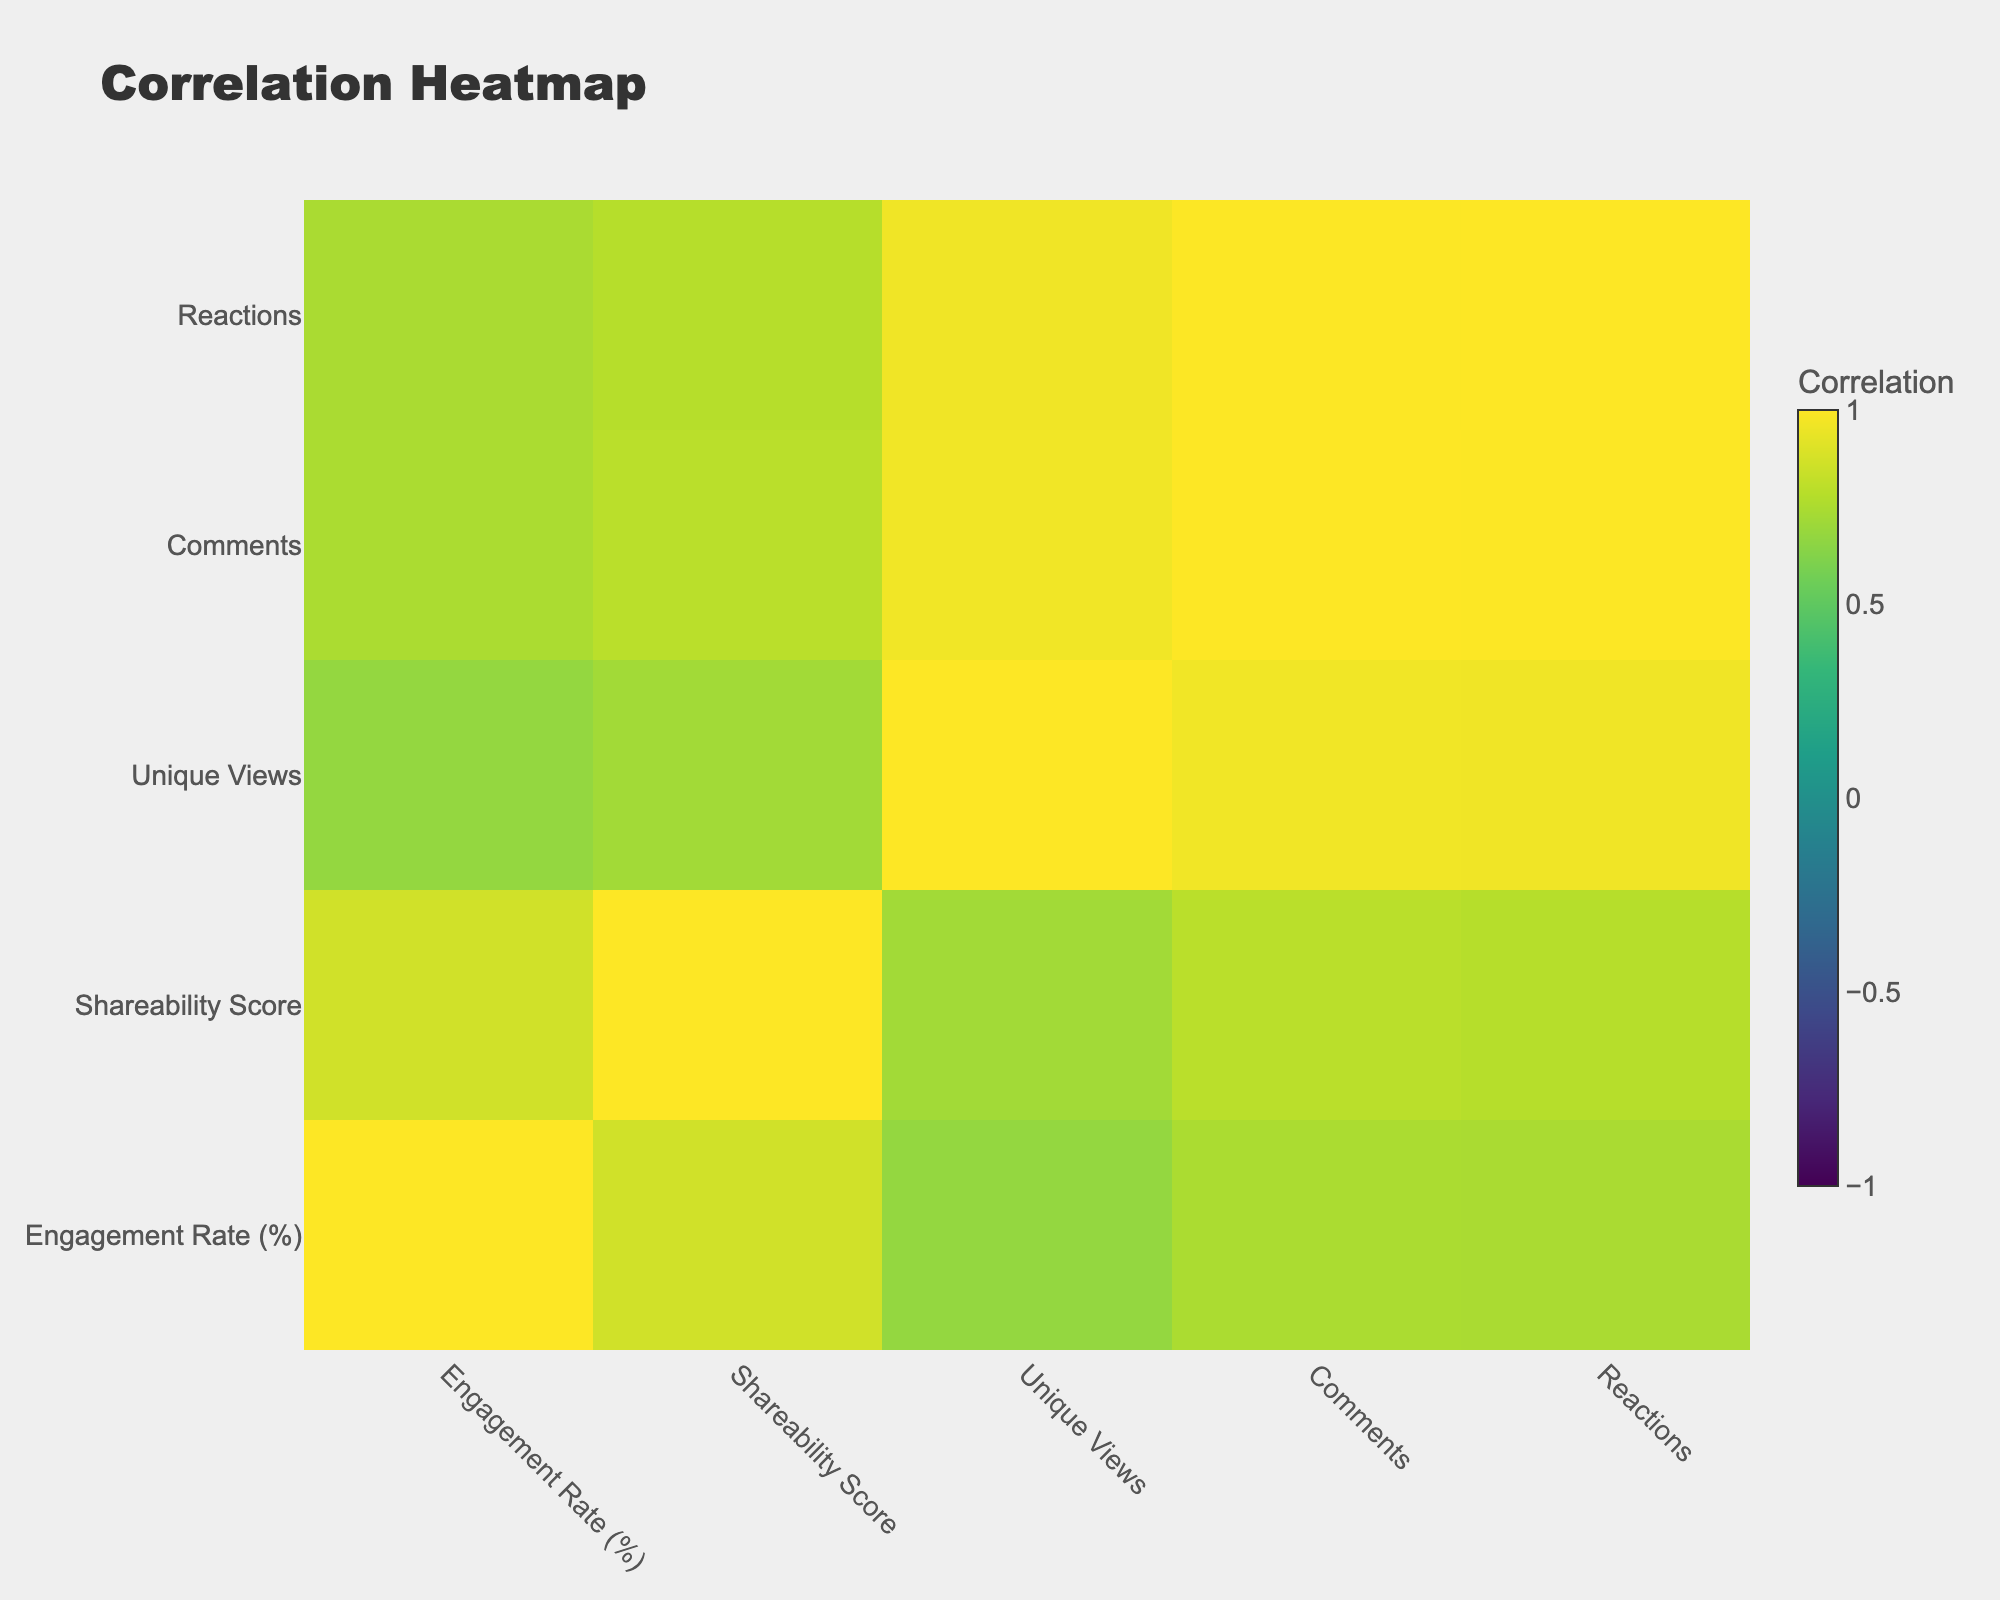What is the Shareability Score of TikTok? TikTok has a Shareability Score of 90, as shown directly in the table under the respective column for that platform.
Answer: 90 What is the Engagement Rate of YouTube? YouTube's Engagement Rate, based on the table, is 7.5%. This value can be found directly in the engagement rate column corresponding to YouTube.
Answer: 7.5 Which platform has the highest number of Unique Views? YouTube has the highest number of Unique Views with 4000. This can be seen by comparing the Unique Views for all platforms listed in the table.
Answer: 4000 Is the statement "Instagram has a higher Engagement Rate than Pinterest" true? Instagram has an Engagement Rate of 4.5% while Pinterest has a lower Engagement Rate of 4.0%. Since 4.5 is greater than 4.0, the statement is true.
Answer: Yes What is the average Shareability Score for all platforms? To calculate the average Shareability Score, we sum the Shareability Scores of all platforms (80 + 75 + 65 + 70 + 90 + 60 + 85 + 78 + 77 + 50) =  820. Then, we divide this total by the number of platforms (10), resulting in an average of 82.
Answer: 82 Which platform has the lowest Engagement Rate, and what is that rate? The lowest Engagement Rate is found with Tumblr at 3.0%. This can be deduced by scanning the Engagement Rate column and identifying the smallest value.
Answer: 3.0 What is the difference in Shareability Score between TikTok and Twitter? TikTok has a Shareability Score of 90, while Twitter's is 65. The difference is 90 - 65 = 25, which is calculated by subtracting the Shareability Score of Twitter from TikTok's.
Answer: 25 Is the statement "LinkedIn has more Unique Views than Reddit" true? LinkedIn has 1000 Unique Views and Reddit has 1800. Since 1000 is less than 1800, the statement is false.
Answer: No If we consider the platforms that provide video content, what is the combined Engagement Rate of Facebook and YouTube? Facebook has an Engagement Rate of 6.0% and YouTube has 7.5%. Combining these gives us 6.0 + 7.5 = 13.5%, which is obtained by simply adding the two Engagement Rates together.
Answer: 13.5 